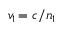<formula> <loc_0><loc_0><loc_500><loc_500>v _ { 1 \, } = c / n _ { 1 }</formula> 